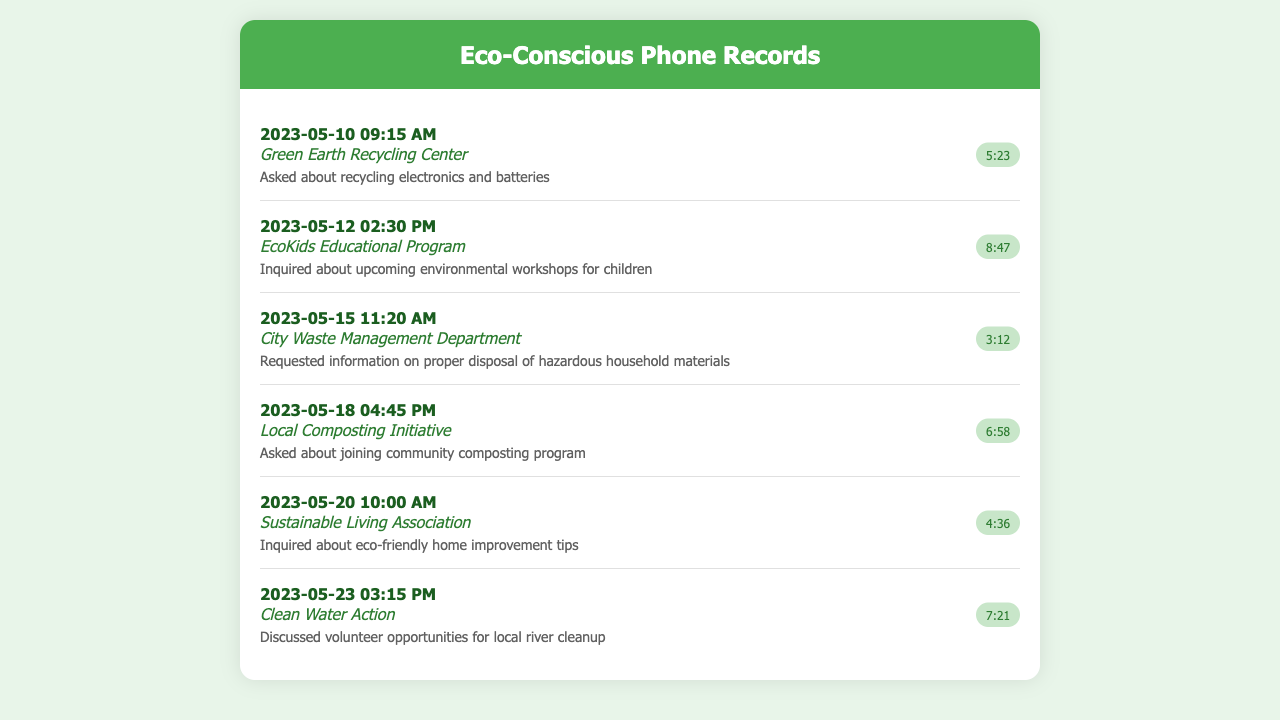What is the date of the call to the Green Earth Recycling Center? The date of the call is listed in the document next to the contact name.
Answer: 2023-05-10 How long was the call with the Sustainable Living Association? The duration of the call can be found next to the date and contact information for this entry.
Answer: 4:36 What did the caller ask about during the call with EcoKids Educational Program? The notes detail the inquiry made during the call with this organization.
Answer: Upcoming environmental workshops for children Which organization was contacted on May 23? The date helps identify which organization was called on that day as recorded in the document.
Answer: Clean Water Action What is the main focus of the call to the Local Composting Initiative? The notes provide insight into what the caller was interested in discussing with this center.
Answer: Joining community composting program How many calls were made in total as listed in the document? By counting the number of records shown in the document, we can determine the total number of calls.
Answer: 6 